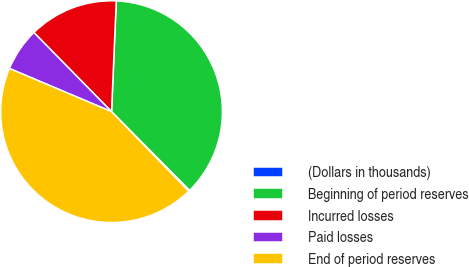Convert chart to OTSL. <chart><loc_0><loc_0><loc_500><loc_500><pie_chart><fcel>(Dollars in thousands)<fcel>Beginning of period reserves<fcel>Incurred losses<fcel>Paid losses<fcel>End of period reserves<nl><fcel>0.18%<fcel>36.88%<fcel>13.03%<fcel>6.28%<fcel>43.63%<nl></chart> 